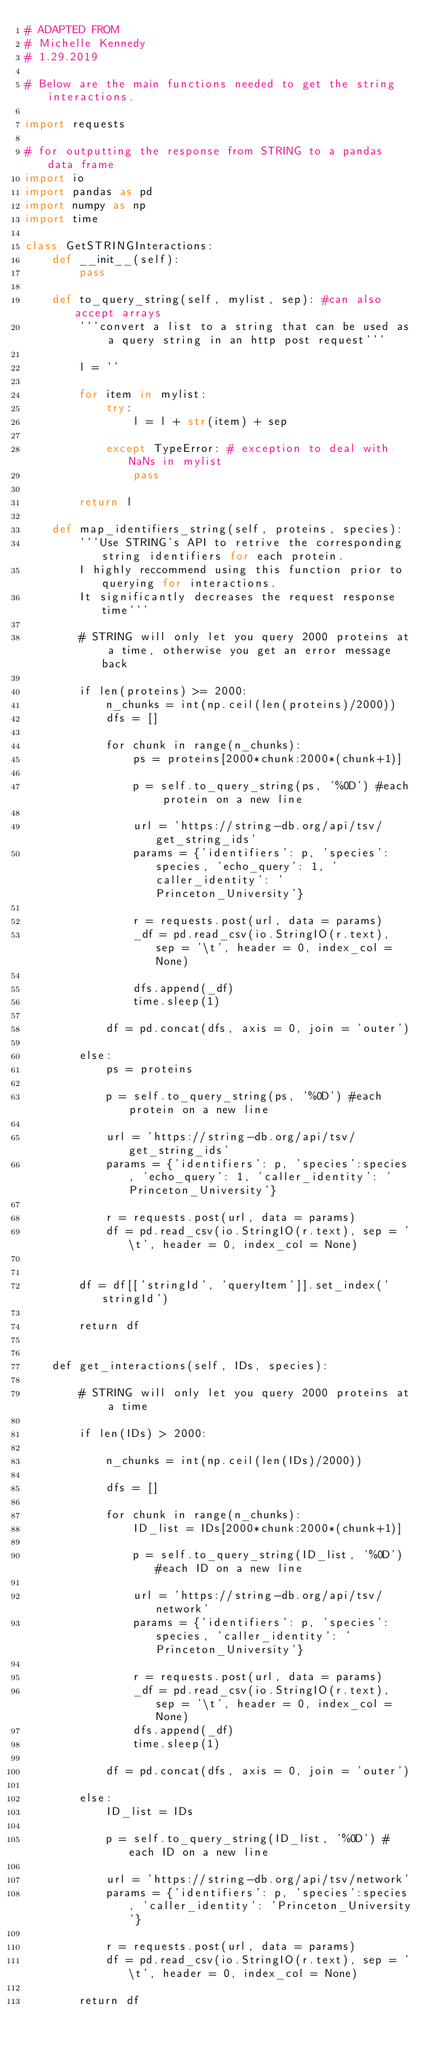Convert code to text. <code><loc_0><loc_0><loc_500><loc_500><_Python_># ADAPTED FROM 
# Michelle Kennedy
# 1.29.2019

# Below are the main functions needed to get the string interactions. 

import requests

# for outputting the response from STRING to a pandas data frame
import io 
import pandas as pd
import numpy as np
import time

class GetSTRINGInteractions:
    def __init__(self):
        pass
    
    def to_query_string(self, mylist, sep): #can also accept arrays
        '''convert a list to a string that can be used as a query string in an http post request'''
        
        l = ''

        for item in mylist:
            try:
                l = l + str(item) + sep
            
            except TypeError: # exception to deal with NaNs in mylist
                pass
        
        return l
    
    def map_identifiers_string(self, proteins, species):
        '''Use STRING's API to retrive the corresponding string identifiers for each protein.
        I highly reccommend using this function prior to querying for interactions. 
        It significantly decreases the request response time'''
        
        # STRING will only let you query 2000 proteins at a time, otherwise you get an error message back
        
        if len(proteins) >= 2000:
            n_chunks = int(np.ceil(len(proteins)/2000))
            dfs = []
            
            for chunk in range(n_chunks):
                ps = proteins[2000*chunk:2000*(chunk+1)]
                
                p = self.to_query_string(ps, '%0D') #each protein on a new line

                url = 'https://string-db.org/api/tsv/get_string_ids'
                params = {'identifiers': p, 'species':species, 'echo_query': 1, 'caller_identity': 'Princeton_University'}

                r = requests.post(url, data = params)
                _df = pd.read_csv(io.StringIO(r.text), sep = '\t', header = 0, index_col = None)
                
                dfs.append(_df)
                time.sleep(1)
                
            df = pd.concat(dfs, axis = 0, join = 'outer')
   
        else:
            ps = proteins
        
            p = self.to_query_string(ps, '%0D') #each protein on a new line

            url = 'https://string-db.org/api/tsv/get_string_ids'
            params = {'identifiers': p, 'species':species, 'echo_query': 1, 'caller_identity': 'Princeton_University'}

            r = requests.post(url, data = params)
            df = pd.read_csv(io.StringIO(r.text), sep = '\t', header = 0, index_col = None)
            
            
        df = df[['stringId', 'queryItem']].set_index('stringId')
        
        return df

    
    def get_interactions(self, IDs, species):
        
        # STRING will only let you query 2000 proteins at a time
        
        if len(IDs) > 2000:
            
            n_chunks = int(np.ceil(len(IDs)/2000))
            
            dfs = []
            
            for chunk in range(n_chunks):
                ID_list = IDs[2000*chunk:2000*(chunk+1)]
                
                p = self.to_query_string(ID_list, '%0D') #each ID on a new line

                url = 'https://string-db.org/api/tsv/network'
                params = {'identifiers': p, 'species':species, 'caller_identity': 'Princeton_University'}

                r = requests.post(url, data = params)
                _df = pd.read_csv(io.StringIO(r.text), sep = '\t', header = 0, index_col = None)
                dfs.append(_df)
                time.sleep(1)
            
            df = pd.concat(dfs, axis = 0, join = 'outer')
                
        else:
            ID_list = IDs
        
            p = self.to_query_string(ID_list, '%0D') #each ID on a new line

            url = 'https://string-db.org/api/tsv/network'
            params = {'identifiers': p, 'species':species, 'caller_identity': 'Princeton_University'}

            r = requests.post(url, data = params)
            df = pd.read_csv(io.StringIO(r.text), sep = '\t', header = 0, index_col = None)
        
        return df</code> 